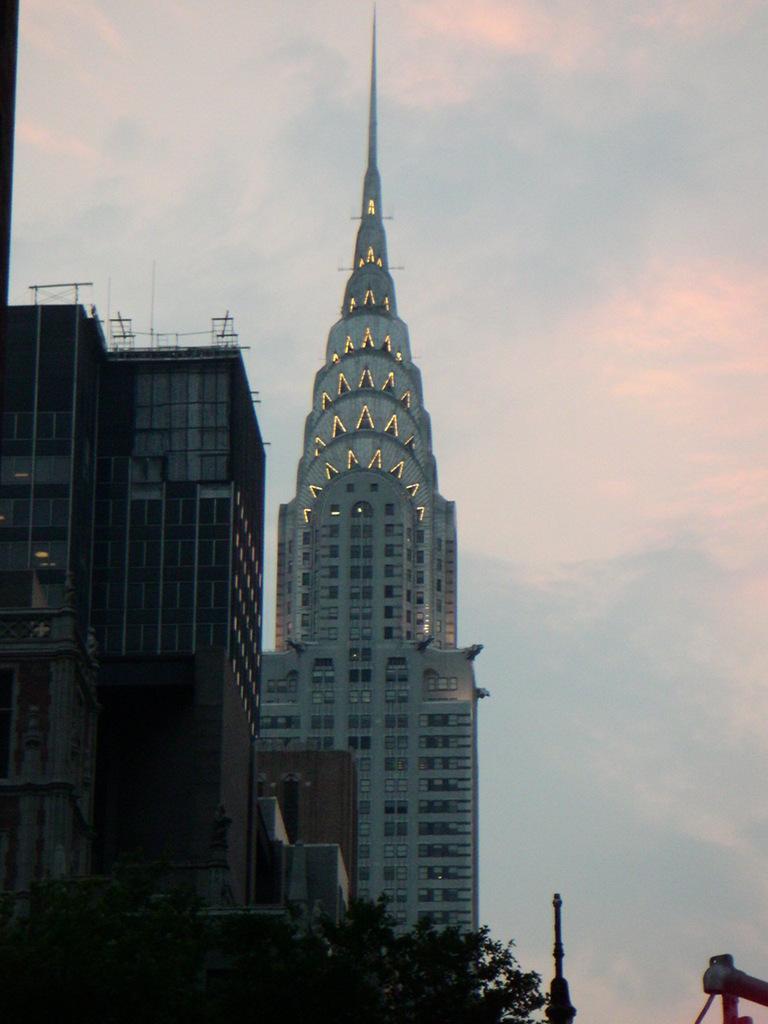Can you describe this image briefly? On the right side, there are buildings which are having glass windows. In the background, there is a tower which is having glass windows and lights and there are clouds in the sky. 